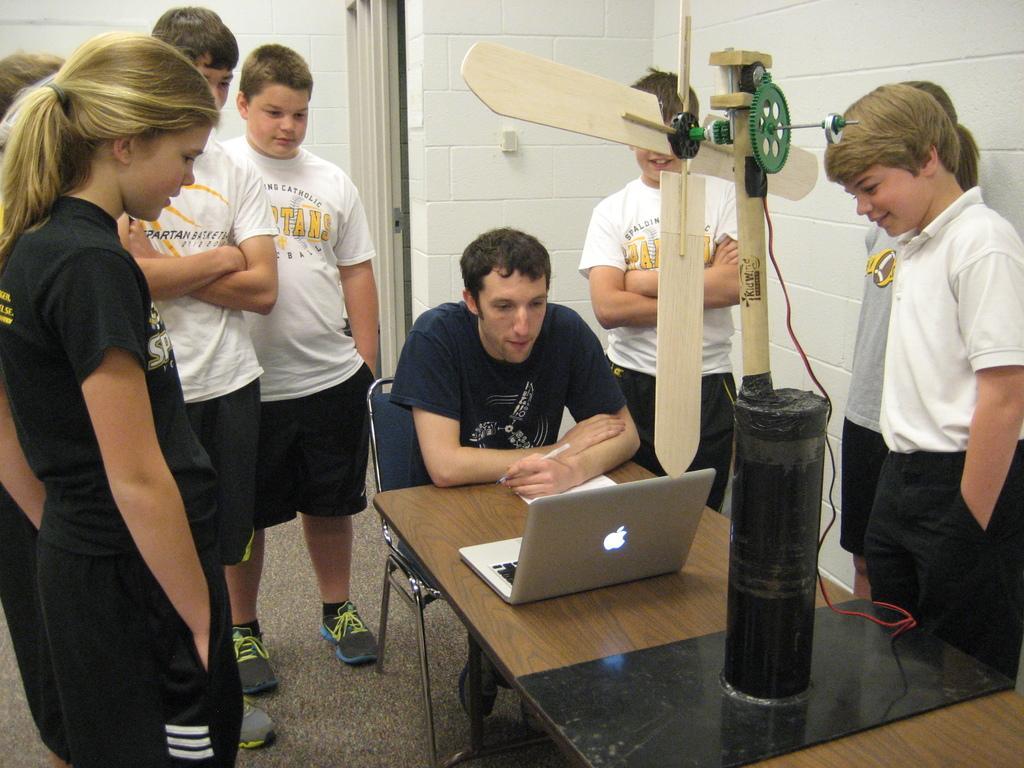Please provide a concise description of this image. This picture is clicked inside. On the left there is a girl wearing black color t-shirt and standing on the ground and we can see the group of people wearing white color t-shirts and standing on the ground. In the center there is a wooden table on the top of which a device is at attached and we can see a paper and a laptop is placed on the top of the table and there is a person wearing t-shirt, holding a pen and sitting on the chair. In the background we can see the wall. 